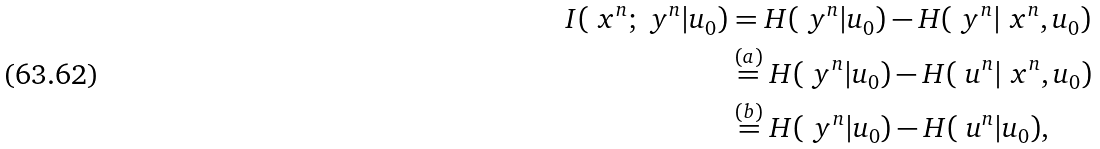<formula> <loc_0><loc_0><loc_500><loc_500>I ( \ x ^ { n } ; \ y ^ { n } | u _ { 0 } ) & = H ( \ y ^ { n } | u _ { 0 } ) - H ( \ y ^ { n } | \ x ^ { n } , u _ { 0 } ) \\ & \stackrel { ( a ) } { = } H ( \ y ^ { n } | u _ { 0 } ) - H ( \ u ^ { n } | \ x ^ { n } , u _ { 0 } ) \\ & \stackrel { ( b ) } { = } H ( \ y ^ { n } | u _ { 0 } ) - H ( \ u ^ { n } | u _ { 0 } ) ,</formula> 